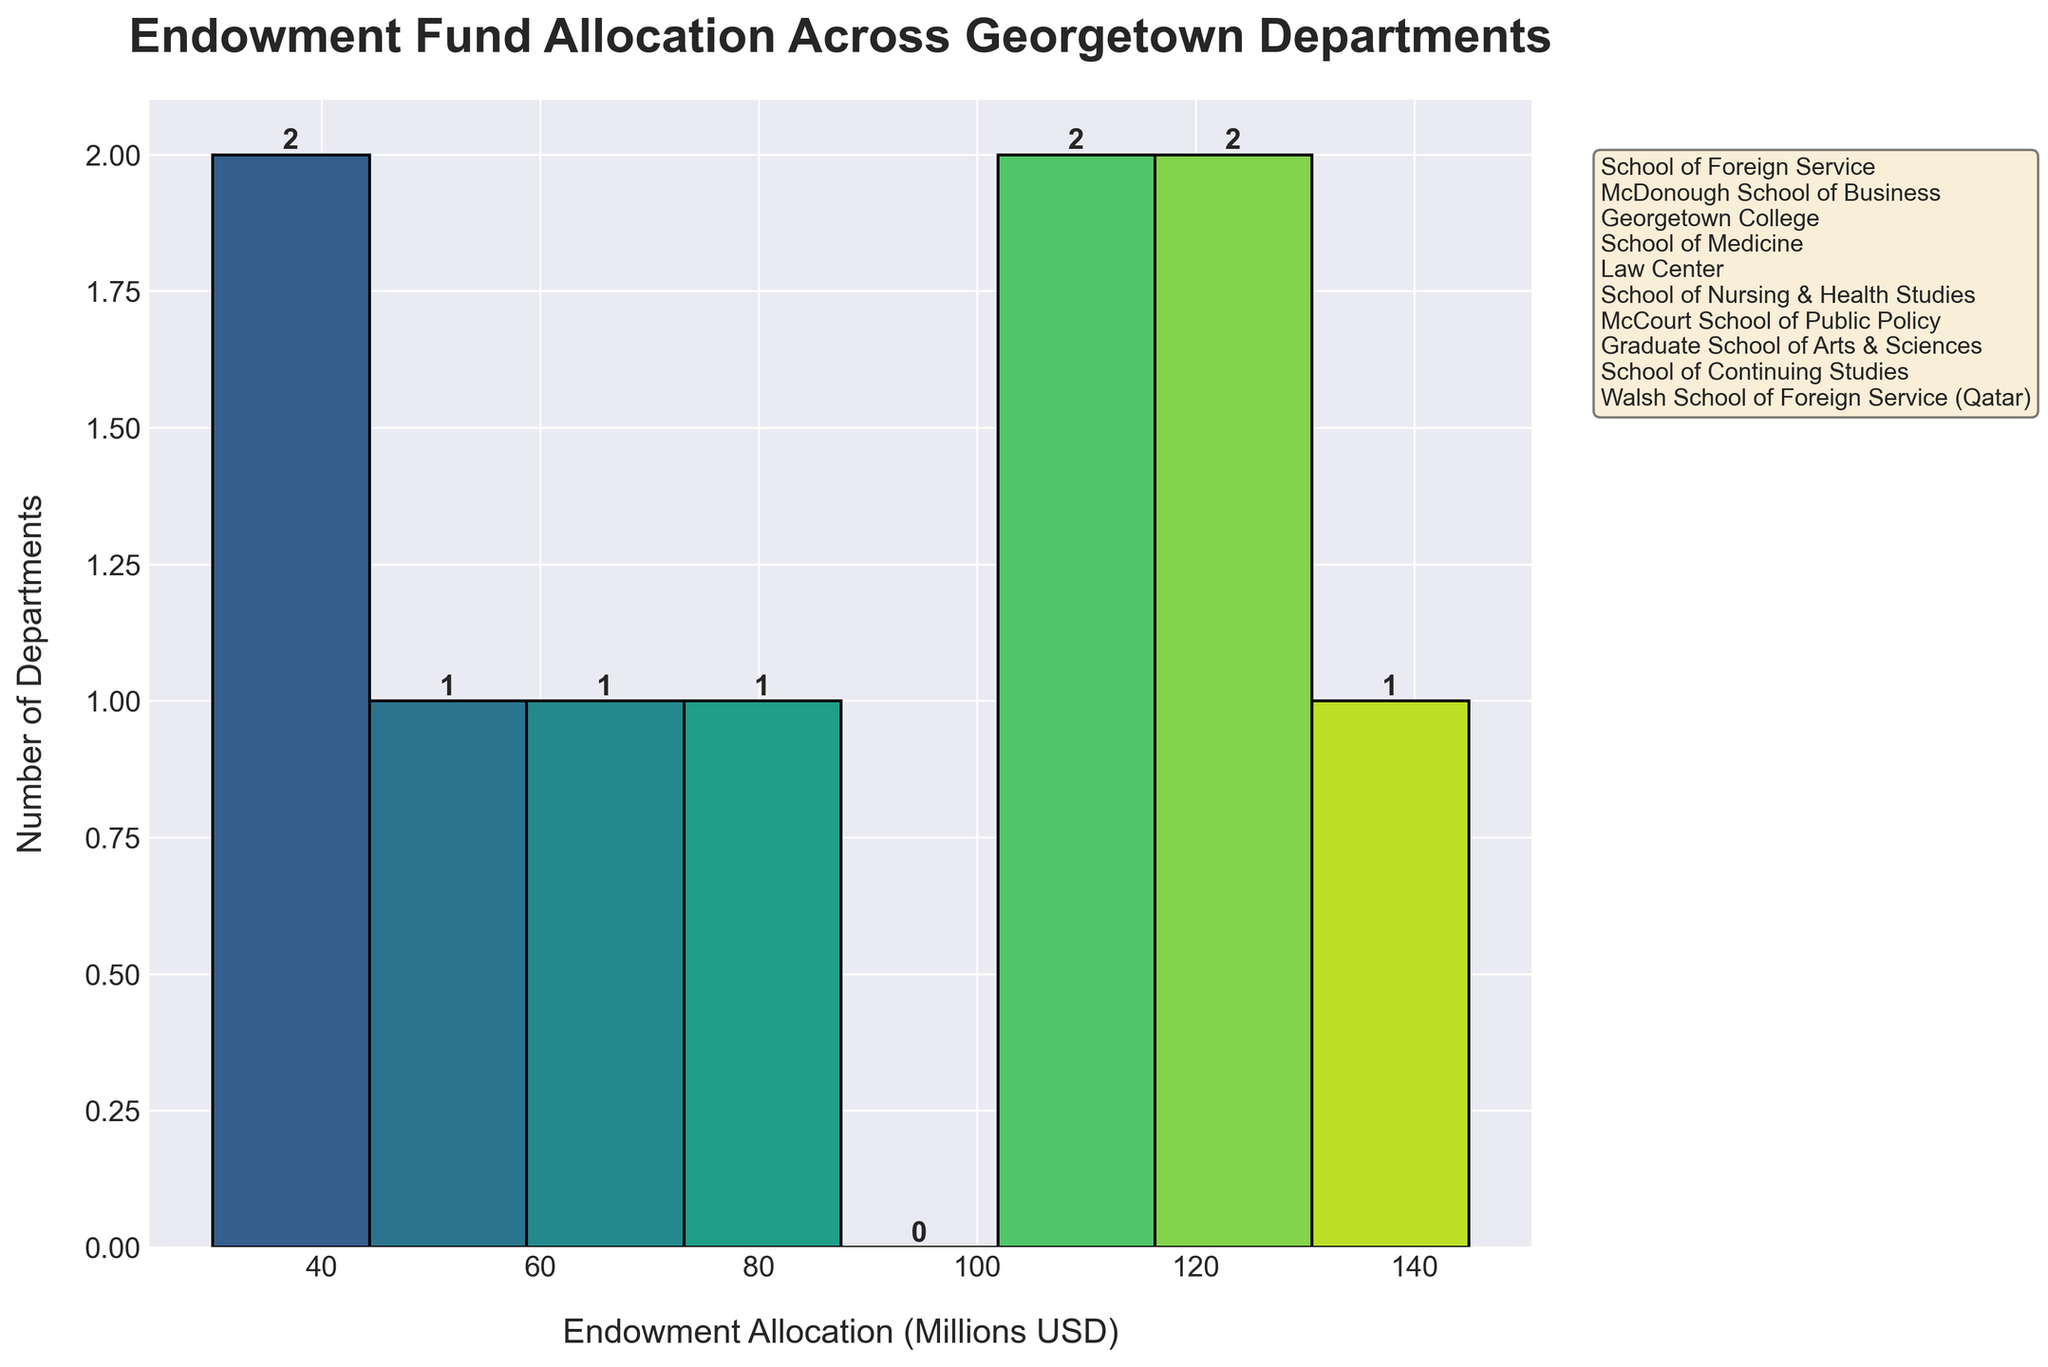What is the title of the histogram? The title of the histogram is displayed at the top of the figure.
Answer: Endowment Fund Allocation Across Georgetown Departments How many bins are there in the histogram? The number of bins can be counted directly from the x-axis of the histogram.
Answer: 8 What is the range of endowment allocation values in the histogram? The endowment allocation values range from the minimum allocation to the maximum allocation shown on the x-axis.
Answer: 30 to 145 Million USD Which endowment allocation range has the highest number of departments? The bin with the tallest bar represents the range with the highest number of departments.
Answer: 100-120 Million USD How many departments have an endowment allocation of over 100 Million USD? Count the number of departments whose allocation falls into bins with ranges starting from 100 Million USD.
Answer: 3 What is the difference between the highest and lowest endowment allocation amounts? Subtract the lowest allocation from the highest allocation shown in the data table.
Answer: 145 - 30 = 115 Million USD Which department has the lowest endowment allocation? The department with the lowest allocation can be determined from the data table presented.
Answer: Walsh School of Foreign Service (Qatar) What is the average endowment allocation of the departments? Sum all endowment allocations and divide by the number of departments.
Answer: (145 + 130 + 120 + 110 + 105 + 75 + 60 + 55 + 40 + 30) / 10 = 87 Million USD Compare the endowment allocations of the Law Center and Georgetown College. Which is higher? Refer to the data table and compare the allocations for both departments.
Answer: Georgetown College How many departments have an endowment allocation of less than 60 Million USD? Count the number of departments whose allocation falls into bins with ranges under 60 Million USD.
Answer: 3 